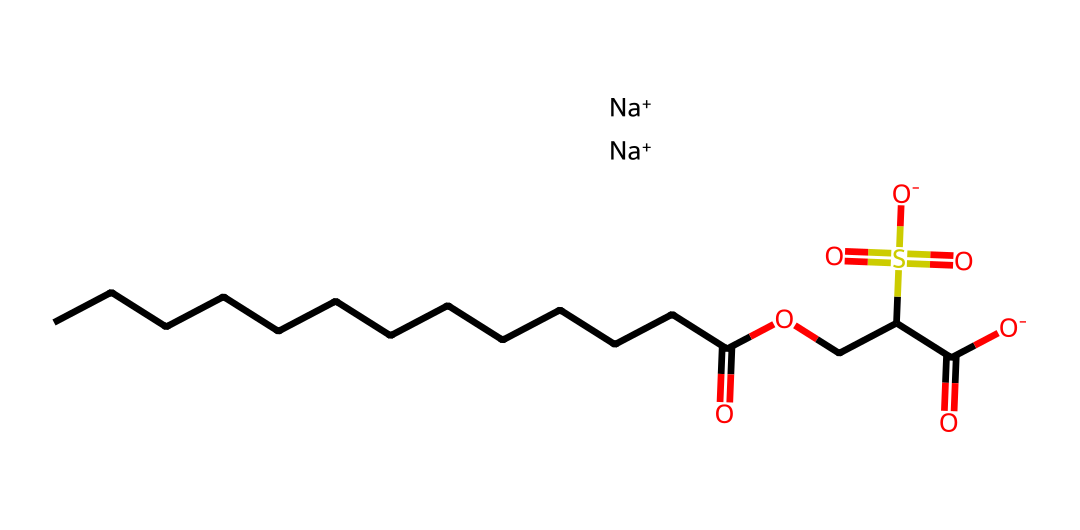What is the total number of carbon atoms in this molecule? By analyzing the SMILES representation, I count the carbon atoms from the longest carbon chain and any surrounding groups. There are 13 carbon atoms from the straight chain and additional ones from the ester and sulfate groups, making a total of 15.
Answer: 15 How many oxygen atoms are in this surfactant? The SMILES notation indicates the presence of oxygen atoms connected to various functional groups: one in the carboxylic acid, one ester linkage and two in the sulfate groups. This adds up to a total of 5 oxygen atoms.
Answer: 5 What functional group indicates this is a surfactant? The presence of both a hydrophobic carbon chain and a hydrophilic sulfate group signals that this compound is a surfactant, as surfactants are characterized by their amphiphilic nature.
Answer: sulfate group What charge does the molecule carry overall? The presence of two sodium cations (Na+) in the SMILES notation suggests that the molecule carries a negative charge in its sulfate groups, and thus the overall charge of the molecule can be considered neutral due to balancing with cations.
Answer: neutral How many sulfate groups are present in this surfactant? Referring to the SMILES structure, I can identify two sulfur atoms with their respective oxygen atoms that represent the sulfate groups. This indicates there are two sulfate groups present in the molecule.
Answer: 2 What type of surfactant is this compound likely to be? Given the structure, which contains a long hydrocarbon chain and ionic sulfate groups, this surfactant is likely to be an anionic surfactant, as such surfactants are characterized by having a negatively charged head.
Answer: anionic surfactant What is the significance of the long carbon chain in this molecule? The long carbon chain contributes to the hydrophobic nature of the surfactant, allowing it to interact favorably with oils and fats, which is essential for cleaning and emulsifying in personal care products.
Answer: hydrophobic nature 